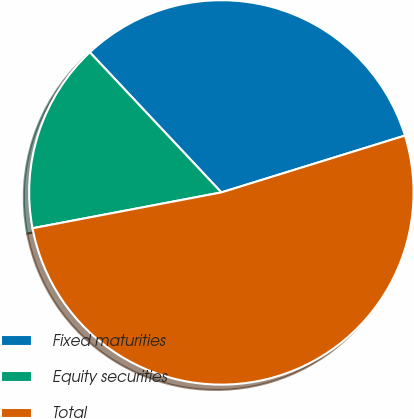Convert chart. <chart><loc_0><loc_0><loc_500><loc_500><pie_chart><fcel>Fixed maturities<fcel>Equity securities<fcel>Total<nl><fcel>32.22%<fcel>15.99%<fcel>51.79%<nl></chart> 